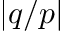<formula> <loc_0><loc_0><loc_500><loc_500>| q / p |</formula> 